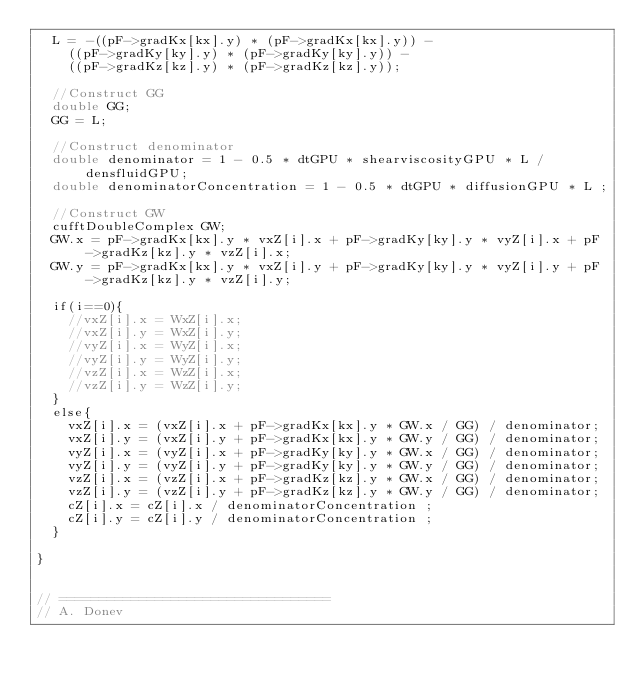Convert code to text. <code><loc_0><loc_0><loc_500><loc_500><_Cuda_>  L = -((pF->gradKx[kx].y) * (pF->gradKx[kx].y)) - 
    ((pF->gradKy[ky].y) * (pF->gradKy[ky].y)) -
    ((pF->gradKz[kz].y) * (pF->gradKz[kz].y));

  //Construct GG
  double GG;
  GG = L;

  //Construct denominator
  double denominator = 1 - 0.5 * dtGPU * shearviscosityGPU * L / densfluidGPU;
  double denominatorConcentration = 1 - 0.5 * dtGPU * diffusionGPU * L ;

  //Construct GW
  cufftDoubleComplex GW;
  GW.x = pF->gradKx[kx].y * vxZ[i].x + pF->gradKy[ky].y * vyZ[i].x + pF->gradKz[kz].y * vzZ[i].x;
  GW.y = pF->gradKx[kx].y * vxZ[i].y + pF->gradKy[ky].y * vyZ[i].y + pF->gradKz[kz].y * vzZ[i].y;
  
  if(i==0){
    //vxZ[i].x = WxZ[i].x;
    //vxZ[i].y = WxZ[i].y;
    //vyZ[i].x = WyZ[i].x;
    //vyZ[i].y = WyZ[i].y;
    //vzZ[i].x = WzZ[i].x;
    //vzZ[i].y = WzZ[i].y;
  }
  else{
    vxZ[i].x = (vxZ[i].x + pF->gradKx[kx].y * GW.x / GG) / denominator;
    vxZ[i].y = (vxZ[i].y + pF->gradKx[kx].y * GW.y / GG) / denominator;
    vyZ[i].x = (vyZ[i].x + pF->gradKy[ky].y * GW.x / GG) / denominator;
    vyZ[i].y = (vyZ[i].y + pF->gradKy[ky].y * GW.y / GG) / denominator;
    vzZ[i].x = (vzZ[i].x + pF->gradKz[kz].y * GW.x / GG) / denominator;
    vzZ[i].y = (vzZ[i].y + pF->gradKz[kz].y * GW.y / GG) / denominator;
    cZ[i].x = cZ[i].x / denominatorConcentration ;
    cZ[i].y = cZ[i].y / denominatorConcentration ;   
  }
  
}


// ==================================
// A. Donev</code> 